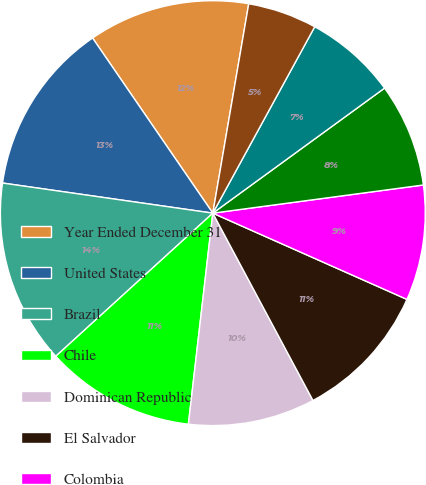<chart> <loc_0><loc_0><loc_500><loc_500><pie_chart><fcel>Year Ended December 31<fcel>United States<fcel>Brazil<fcel>Chile<fcel>Dominican Republic<fcel>El Salvador<fcel>Colombia<fcel>Philippines<fcel>Argentina<fcel>Mexico<nl><fcel>12.28%<fcel>13.16%<fcel>14.03%<fcel>11.4%<fcel>9.65%<fcel>10.53%<fcel>8.77%<fcel>7.9%<fcel>7.02%<fcel>5.26%<nl></chart> 